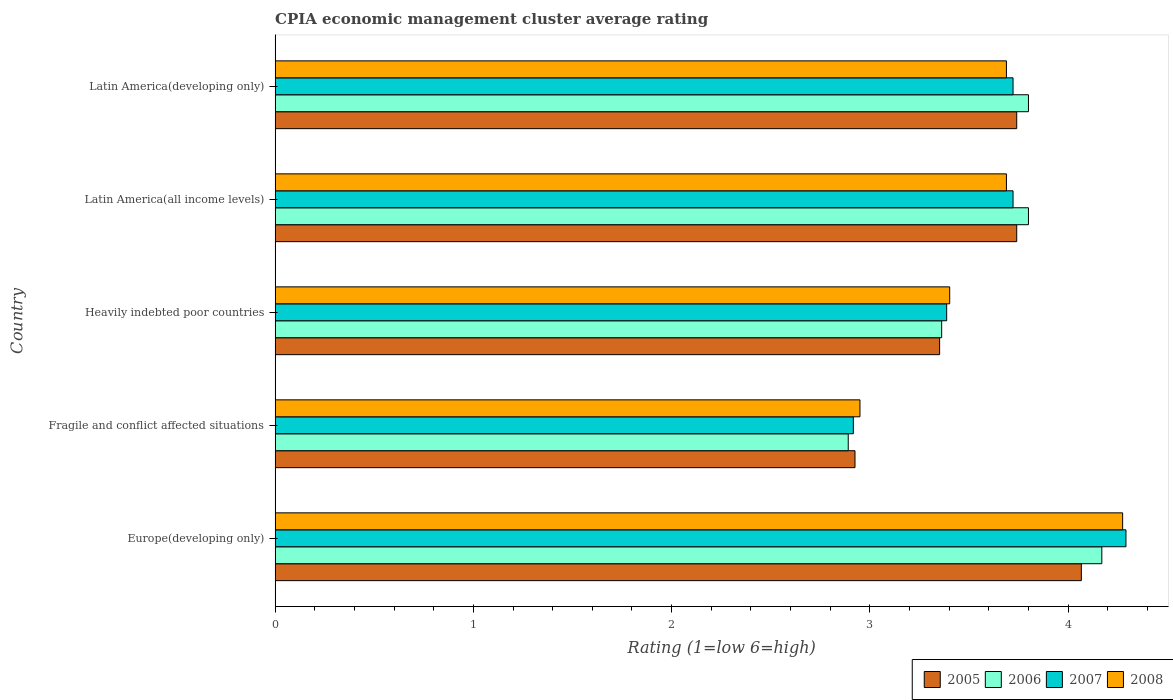Are the number of bars on each tick of the Y-axis equal?
Keep it short and to the point. Yes. How many bars are there on the 5th tick from the bottom?
Your answer should be very brief. 4. What is the label of the 3rd group of bars from the top?
Your response must be concise. Heavily indebted poor countries. In how many cases, is the number of bars for a given country not equal to the number of legend labels?
Provide a short and direct response. 0. What is the CPIA rating in 2005 in Heavily indebted poor countries?
Provide a short and direct response. 3.35. Across all countries, what is the maximum CPIA rating in 2008?
Keep it short and to the point. 4.28. Across all countries, what is the minimum CPIA rating in 2008?
Offer a terse response. 2.95. In which country was the CPIA rating in 2006 maximum?
Your answer should be compact. Europe(developing only). In which country was the CPIA rating in 2005 minimum?
Your answer should be compact. Fragile and conflict affected situations. What is the total CPIA rating in 2005 in the graph?
Your response must be concise. 17.83. What is the difference between the CPIA rating in 2006 in Latin America(all income levels) and that in Latin America(developing only)?
Give a very brief answer. 0. What is the difference between the CPIA rating in 2006 in Latin America(developing only) and the CPIA rating in 2008 in Europe(developing only)?
Your answer should be very brief. -0.48. What is the average CPIA rating in 2006 per country?
Offer a terse response. 3.6. What is the difference between the CPIA rating in 2005 and CPIA rating in 2008 in Heavily indebted poor countries?
Offer a very short reply. -0.05. In how many countries, is the CPIA rating in 2008 greater than 3.8 ?
Ensure brevity in your answer.  1. What is the ratio of the CPIA rating in 2005 in Fragile and conflict affected situations to that in Latin America(developing only)?
Your answer should be very brief. 0.78. Is the difference between the CPIA rating in 2005 in Europe(developing only) and Latin America(developing only) greater than the difference between the CPIA rating in 2008 in Europe(developing only) and Latin America(developing only)?
Provide a succinct answer. No. What is the difference between the highest and the second highest CPIA rating in 2005?
Make the answer very short. 0.33. What is the difference between the highest and the lowest CPIA rating in 2008?
Your answer should be very brief. 1.33. In how many countries, is the CPIA rating in 2006 greater than the average CPIA rating in 2006 taken over all countries?
Provide a succinct answer. 3. Is the sum of the CPIA rating in 2008 in Fragile and conflict affected situations and Heavily indebted poor countries greater than the maximum CPIA rating in 2006 across all countries?
Offer a terse response. Yes. Is it the case that in every country, the sum of the CPIA rating in 2007 and CPIA rating in 2006 is greater than the CPIA rating in 2005?
Keep it short and to the point. Yes. Are all the bars in the graph horizontal?
Keep it short and to the point. Yes. How many countries are there in the graph?
Give a very brief answer. 5. How many legend labels are there?
Make the answer very short. 4. What is the title of the graph?
Give a very brief answer. CPIA economic management cluster average rating. What is the label or title of the X-axis?
Make the answer very short. Rating (1=low 6=high). What is the Rating (1=low 6=high) in 2005 in Europe(developing only)?
Make the answer very short. 4.07. What is the Rating (1=low 6=high) of 2006 in Europe(developing only)?
Your answer should be compact. 4.17. What is the Rating (1=low 6=high) of 2007 in Europe(developing only)?
Make the answer very short. 4.29. What is the Rating (1=low 6=high) of 2008 in Europe(developing only)?
Your response must be concise. 4.28. What is the Rating (1=low 6=high) of 2005 in Fragile and conflict affected situations?
Provide a succinct answer. 2.92. What is the Rating (1=low 6=high) of 2006 in Fragile and conflict affected situations?
Your answer should be very brief. 2.89. What is the Rating (1=low 6=high) of 2007 in Fragile and conflict affected situations?
Offer a very short reply. 2.92. What is the Rating (1=low 6=high) in 2008 in Fragile and conflict affected situations?
Ensure brevity in your answer.  2.95. What is the Rating (1=low 6=high) in 2005 in Heavily indebted poor countries?
Make the answer very short. 3.35. What is the Rating (1=low 6=high) in 2006 in Heavily indebted poor countries?
Offer a terse response. 3.36. What is the Rating (1=low 6=high) of 2007 in Heavily indebted poor countries?
Keep it short and to the point. 3.39. What is the Rating (1=low 6=high) in 2008 in Heavily indebted poor countries?
Offer a terse response. 3.4. What is the Rating (1=low 6=high) in 2005 in Latin America(all income levels)?
Keep it short and to the point. 3.74. What is the Rating (1=low 6=high) in 2007 in Latin America(all income levels)?
Give a very brief answer. 3.72. What is the Rating (1=low 6=high) in 2008 in Latin America(all income levels)?
Offer a terse response. 3.69. What is the Rating (1=low 6=high) in 2005 in Latin America(developing only)?
Offer a terse response. 3.74. What is the Rating (1=low 6=high) of 2006 in Latin America(developing only)?
Provide a succinct answer. 3.8. What is the Rating (1=low 6=high) in 2007 in Latin America(developing only)?
Ensure brevity in your answer.  3.72. What is the Rating (1=low 6=high) of 2008 in Latin America(developing only)?
Your response must be concise. 3.69. Across all countries, what is the maximum Rating (1=low 6=high) of 2005?
Keep it short and to the point. 4.07. Across all countries, what is the maximum Rating (1=low 6=high) in 2006?
Your response must be concise. 4.17. Across all countries, what is the maximum Rating (1=low 6=high) in 2007?
Offer a very short reply. 4.29. Across all countries, what is the maximum Rating (1=low 6=high) of 2008?
Offer a very short reply. 4.28. Across all countries, what is the minimum Rating (1=low 6=high) in 2005?
Give a very brief answer. 2.92. Across all countries, what is the minimum Rating (1=low 6=high) in 2006?
Provide a succinct answer. 2.89. Across all countries, what is the minimum Rating (1=low 6=high) in 2007?
Your response must be concise. 2.92. Across all countries, what is the minimum Rating (1=low 6=high) in 2008?
Provide a short and direct response. 2.95. What is the total Rating (1=low 6=high) of 2005 in the graph?
Provide a short and direct response. 17.82. What is the total Rating (1=low 6=high) of 2006 in the graph?
Ensure brevity in your answer.  18.02. What is the total Rating (1=low 6=high) of 2007 in the graph?
Give a very brief answer. 18.04. What is the total Rating (1=low 6=high) in 2008 in the graph?
Offer a very short reply. 18.01. What is the difference between the Rating (1=low 6=high) of 2005 in Europe(developing only) and that in Fragile and conflict affected situations?
Keep it short and to the point. 1.14. What is the difference between the Rating (1=low 6=high) of 2006 in Europe(developing only) and that in Fragile and conflict affected situations?
Your answer should be very brief. 1.28. What is the difference between the Rating (1=low 6=high) in 2007 in Europe(developing only) and that in Fragile and conflict affected situations?
Give a very brief answer. 1.38. What is the difference between the Rating (1=low 6=high) of 2008 in Europe(developing only) and that in Fragile and conflict affected situations?
Offer a terse response. 1.32. What is the difference between the Rating (1=low 6=high) in 2005 in Europe(developing only) and that in Heavily indebted poor countries?
Provide a short and direct response. 0.71. What is the difference between the Rating (1=low 6=high) in 2006 in Europe(developing only) and that in Heavily indebted poor countries?
Provide a short and direct response. 0.81. What is the difference between the Rating (1=low 6=high) in 2007 in Europe(developing only) and that in Heavily indebted poor countries?
Offer a very short reply. 0.9. What is the difference between the Rating (1=low 6=high) of 2008 in Europe(developing only) and that in Heavily indebted poor countries?
Keep it short and to the point. 0.87. What is the difference between the Rating (1=low 6=high) in 2005 in Europe(developing only) and that in Latin America(all income levels)?
Provide a short and direct response. 0.33. What is the difference between the Rating (1=low 6=high) in 2006 in Europe(developing only) and that in Latin America(all income levels)?
Keep it short and to the point. 0.37. What is the difference between the Rating (1=low 6=high) in 2007 in Europe(developing only) and that in Latin America(all income levels)?
Provide a short and direct response. 0.57. What is the difference between the Rating (1=low 6=high) of 2008 in Europe(developing only) and that in Latin America(all income levels)?
Provide a succinct answer. 0.59. What is the difference between the Rating (1=low 6=high) in 2005 in Europe(developing only) and that in Latin America(developing only)?
Give a very brief answer. 0.33. What is the difference between the Rating (1=low 6=high) in 2006 in Europe(developing only) and that in Latin America(developing only)?
Offer a terse response. 0.37. What is the difference between the Rating (1=low 6=high) of 2007 in Europe(developing only) and that in Latin America(developing only)?
Provide a short and direct response. 0.57. What is the difference between the Rating (1=low 6=high) in 2008 in Europe(developing only) and that in Latin America(developing only)?
Your response must be concise. 0.59. What is the difference between the Rating (1=low 6=high) of 2005 in Fragile and conflict affected situations and that in Heavily indebted poor countries?
Provide a short and direct response. -0.43. What is the difference between the Rating (1=low 6=high) in 2006 in Fragile and conflict affected situations and that in Heavily indebted poor countries?
Offer a terse response. -0.47. What is the difference between the Rating (1=low 6=high) in 2007 in Fragile and conflict affected situations and that in Heavily indebted poor countries?
Make the answer very short. -0.47. What is the difference between the Rating (1=low 6=high) in 2008 in Fragile and conflict affected situations and that in Heavily indebted poor countries?
Ensure brevity in your answer.  -0.45. What is the difference between the Rating (1=low 6=high) of 2005 in Fragile and conflict affected situations and that in Latin America(all income levels)?
Provide a short and direct response. -0.82. What is the difference between the Rating (1=low 6=high) in 2006 in Fragile and conflict affected situations and that in Latin America(all income levels)?
Ensure brevity in your answer.  -0.91. What is the difference between the Rating (1=low 6=high) in 2007 in Fragile and conflict affected situations and that in Latin America(all income levels)?
Keep it short and to the point. -0.81. What is the difference between the Rating (1=low 6=high) in 2008 in Fragile and conflict affected situations and that in Latin America(all income levels)?
Provide a short and direct response. -0.74. What is the difference between the Rating (1=low 6=high) of 2005 in Fragile and conflict affected situations and that in Latin America(developing only)?
Offer a very short reply. -0.82. What is the difference between the Rating (1=low 6=high) in 2006 in Fragile and conflict affected situations and that in Latin America(developing only)?
Provide a succinct answer. -0.91. What is the difference between the Rating (1=low 6=high) in 2007 in Fragile and conflict affected situations and that in Latin America(developing only)?
Your answer should be compact. -0.81. What is the difference between the Rating (1=low 6=high) of 2008 in Fragile and conflict affected situations and that in Latin America(developing only)?
Provide a short and direct response. -0.74. What is the difference between the Rating (1=low 6=high) of 2005 in Heavily indebted poor countries and that in Latin America(all income levels)?
Provide a short and direct response. -0.39. What is the difference between the Rating (1=low 6=high) in 2006 in Heavily indebted poor countries and that in Latin America(all income levels)?
Keep it short and to the point. -0.44. What is the difference between the Rating (1=low 6=high) in 2007 in Heavily indebted poor countries and that in Latin America(all income levels)?
Provide a short and direct response. -0.33. What is the difference between the Rating (1=low 6=high) in 2008 in Heavily indebted poor countries and that in Latin America(all income levels)?
Your answer should be very brief. -0.29. What is the difference between the Rating (1=low 6=high) in 2005 in Heavily indebted poor countries and that in Latin America(developing only)?
Make the answer very short. -0.39. What is the difference between the Rating (1=low 6=high) of 2006 in Heavily indebted poor countries and that in Latin America(developing only)?
Ensure brevity in your answer.  -0.44. What is the difference between the Rating (1=low 6=high) in 2007 in Heavily indebted poor countries and that in Latin America(developing only)?
Your answer should be compact. -0.33. What is the difference between the Rating (1=low 6=high) in 2008 in Heavily indebted poor countries and that in Latin America(developing only)?
Provide a short and direct response. -0.29. What is the difference between the Rating (1=low 6=high) of 2007 in Latin America(all income levels) and that in Latin America(developing only)?
Provide a short and direct response. 0. What is the difference between the Rating (1=low 6=high) of 2005 in Europe(developing only) and the Rating (1=low 6=high) of 2006 in Fragile and conflict affected situations?
Your answer should be compact. 1.18. What is the difference between the Rating (1=low 6=high) in 2005 in Europe(developing only) and the Rating (1=low 6=high) in 2007 in Fragile and conflict affected situations?
Offer a very short reply. 1.15. What is the difference between the Rating (1=low 6=high) in 2005 in Europe(developing only) and the Rating (1=low 6=high) in 2008 in Fragile and conflict affected situations?
Provide a succinct answer. 1.12. What is the difference between the Rating (1=low 6=high) in 2006 in Europe(developing only) and the Rating (1=low 6=high) in 2007 in Fragile and conflict affected situations?
Your response must be concise. 1.25. What is the difference between the Rating (1=low 6=high) in 2006 in Europe(developing only) and the Rating (1=low 6=high) in 2008 in Fragile and conflict affected situations?
Provide a succinct answer. 1.22. What is the difference between the Rating (1=low 6=high) in 2007 in Europe(developing only) and the Rating (1=low 6=high) in 2008 in Fragile and conflict affected situations?
Ensure brevity in your answer.  1.34. What is the difference between the Rating (1=low 6=high) in 2005 in Europe(developing only) and the Rating (1=low 6=high) in 2006 in Heavily indebted poor countries?
Keep it short and to the point. 0.7. What is the difference between the Rating (1=low 6=high) of 2005 in Europe(developing only) and the Rating (1=low 6=high) of 2007 in Heavily indebted poor countries?
Offer a very short reply. 0.68. What is the difference between the Rating (1=low 6=high) in 2005 in Europe(developing only) and the Rating (1=low 6=high) in 2008 in Heavily indebted poor countries?
Your answer should be compact. 0.66. What is the difference between the Rating (1=low 6=high) in 2006 in Europe(developing only) and the Rating (1=low 6=high) in 2007 in Heavily indebted poor countries?
Offer a very short reply. 0.78. What is the difference between the Rating (1=low 6=high) in 2006 in Europe(developing only) and the Rating (1=low 6=high) in 2008 in Heavily indebted poor countries?
Your answer should be very brief. 0.77. What is the difference between the Rating (1=low 6=high) of 2007 in Europe(developing only) and the Rating (1=low 6=high) of 2008 in Heavily indebted poor countries?
Your answer should be very brief. 0.89. What is the difference between the Rating (1=low 6=high) in 2005 in Europe(developing only) and the Rating (1=low 6=high) in 2006 in Latin America(all income levels)?
Provide a short and direct response. 0.27. What is the difference between the Rating (1=low 6=high) in 2005 in Europe(developing only) and the Rating (1=low 6=high) in 2007 in Latin America(all income levels)?
Provide a short and direct response. 0.34. What is the difference between the Rating (1=low 6=high) of 2005 in Europe(developing only) and the Rating (1=low 6=high) of 2008 in Latin America(all income levels)?
Ensure brevity in your answer.  0.38. What is the difference between the Rating (1=low 6=high) in 2006 in Europe(developing only) and the Rating (1=low 6=high) in 2007 in Latin America(all income levels)?
Keep it short and to the point. 0.45. What is the difference between the Rating (1=low 6=high) in 2006 in Europe(developing only) and the Rating (1=low 6=high) in 2008 in Latin America(all income levels)?
Keep it short and to the point. 0.48. What is the difference between the Rating (1=low 6=high) in 2007 in Europe(developing only) and the Rating (1=low 6=high) in 2008 in Latin America(all income levels)?
Your answer should be very brief. 0.6. What is the difference between the Rating (1=low 6=high) of 2005 in Europe(developing only) and the Rating (1=low 6=high) of 2006 in Latin America(developing only)?
Offer a terse response. 0.27. What is the difference between the Rating (1=low 6=high) of 2005 in Europe(developing only) and the Rating (1=low 6=high) of 2007 in Latin America(developing only)?
Provide a short and direct response. 0.34. What is the difference between the Rating (1=low 6=high) in 2005 in Europe(developing only) and the Rating (1=low 6=high) in 2008 in Latin America(developing only)?
Keep it short and to the point. 0.38. What is the difference between the Rating (1=low 6=high) of 2006 in Europe(developing only) and the Rating (1=low 6=high) of 2007 in Latin America(developing only)?
Give a very brief answer. 0.45. What is the difference between the Rating (1=low 6=high) of 2006 in Europe(developing only) and the Rating (1=low 6=high) of 2008 in Latin America(developing only)?
Keep it short and to the point. 0.48. What is the difference between the Rating (1=low 6=high) in 2007 in Europe(developing only) and the Rating (1=low 6=high) in 2008 in Latin America(developing only)?
Ensure brevity in your answer.  0.6. What is the difference between the Rating (1=low 6=high) of 2005 in Fragile and conflict affected situations and the Rating (1=low 6=high) of 2006 in Heavily indebted poor countries?
Offer a terse response. -0.44. What is the difference between the Rating (1=low 6=high) of 2005 in Fragile and conflict affected situations and the Rating (1=low 6=high) of 2007 in Heavily indebted poor countries?
Your answer should be very brief. -0.46. What is the difference between the Rating (1=low 6=high) of 2005 in Fragile and conflict affected situations and the Rating (1=low 6=high) of 2008 in Heavily indebted poor countries?
Offer a terse response. -0.48. What is the difference between the Rating (1=low 6=high) in 2006 in Fragile and conflict affected situations and the Rating (1=low 6=high) in 2007 in Heavily indebted poor countries?
Your answer should be compact. -0.5. What is the difference between the Rating (1=low 6=high) of 2006 in Fragile and conflict affected situations and the Rating (1=low 6=high) of 2008 in Heavily indebted poor countries?
Provide a short and direct response. -0.51. What is the difference between the Rating (1=low 6=high) of 2007 in Fragile and conflict affected situations and the Rating (1=low 6=high) of 2008 in Heavily indebted poor countries?
Provide a succinct answer. -0.49. What is the difference between the Rating (1=low 6=high) of 2005 in Fragile and conflict affected situations and the Rating (1=low 6=high) of 2006 in Latin America(all income levels)?
Give a very brief answer. -0.88. What is the difference between the Rating (1=low 6=high) in 2005 in Fragile and conflict affected situations and the Rating (1=low 6=high) in 2007 in Latin America(all income levels)?
Offer a terse response. -0.8. What is the difference between the Rating (1=low 6=high) of 2005 in Fragile and conflict affected situations and the Rating (1=low 6=high) of 2008 in Latin America(all income levels)?
Provide a short and direct response. -0.76. What is the difference between the Rating (1=low 6=high) of 2006 in Fragile and conflict affected situations and the Rating (1=low 6=high) of 2007 in Latin America(all income levels)?
Give a very brief answer. -0.83. What is the difference between the Rating (1=low 6=high) in 2006 in Fragile and conflict affected situations and the Rating (1=low 6=high) in 2008 in Latin America(all income levels)?
Make the answer very short. -0.8. What is the difference between the Rating (1=low 6=high) in 2007 in Fragile and conflict affected situations and the Rating (1=low 6=high) in 2008 in Latin America(all income levels)?
Offer a terse response. -0.77. What is the difference between the Rating (1=low 6=high) in 2005 in Fragile and conflict affected situations and the Rating (1=low 6=high) in 2006 in Latin America(developing only)?
Offer a very short reply. -0.88. What is the difference between the Rating (1=low 6=high) in 2005 in Fragile and conflict affected situations and the Rating (1=low 6=high) in 2007 in Latin America(developing only)?
Your answer should be very brief. -0.8. What is the difference between the Rating (1=low 6=high) of 2005 in Fragile and conflict affected situations and the Rating (1=low 6=high) of 2008 in Latin America(developing only)?
Give a very brief answer. -0.76. What is the difference between the Rating (1=low 6=high) of 2006 in Fragile and conflict affected situations and the Rating (1=low 6=high) of 2007 in Latin America(developing only)?
Offer a terse response. -0.83. What is the difference between the Rating (1=low 6=high) of 2006 in Fragile and conflict affected situations and the Rating (1=low 6=high) of 2008 in Latin America(developing only)?
Your answer should be compact. -0.8. What is the difference between the Rating (1=low 6=high) of 2007 in Fragile and conflict affected situations and the Rating (1=low 6=high) of 2008 in Latin America(developing only)?
Keep it short and to the point. -0.77. What is the difference between the Rating (1=low 6=high) in 2005 in Heavily indebted poor countries and the Rating (1=low 6=high) in 2006 in Latin America(all income levels)?
Give a very brief answer. -0.45. What is the difference between the Rating (1=low 6=high) of 2005 in Heavily indebted poor countries and the Rating (1=low 6=high) of 2007 in Latin America(all income levels)?
Your answer should be very brief. -0.37. What is the difference between the Rating (1=low 6=high) of 2005 in Heavily indebted poor countries and the Rating (1=low 6=high) of 2008 in Latin America(all income levels)?
Offer a very short reply. -0.34. What is the difference between the Rating (1=low 6=high) of 2006 in Heavily indebted poor countries and the Rating (1=low 6=high) of 2007 in Latin America(all income levels)?
Provide a succinct answer. -0.36. What is the difference between the Rating (1=low 6=high) in 2006 in Heavily indebted poor countries and the Rating (1=low 6=high) in 2008 in Latin America(all income levels)?
Provide a short and direct response. -0.33. What is the difference between the Rating (1=low 6=high) of 2007 in Heavily indebted poor countries and the Rating (1=low 6=high) of 2008 in Latin America(all income levels)?
Offer a very short reply. -0.3. What is the difference between the Rating (1=low 6=high) in 2005 in Heavily indebted poor countries and the Rating (1=low 6=high) in 2006 in Latin America(developing only)?
Provide a succinct answer. -0.45. What is the difference between the Rating (1=low 6=high) of 2005 in Heavily indebted poor countries and the Rating (1=low 6=high) of 2007 in Latin America(developing only)?
Provide a short and direct response. -0.37. What is the difference between the Rating (1=low 6=high) of 2005 in Heavily indebted poor countries and the Rating (1=low 6=high) of 2008 in Latin America(developing only)?
Your answer should be compact. -0.34. What is the difference between the Rating (1=low 6=high) of 2006 in Heavily indebted poor countries and the Rating (1=low 6=high) of 2007 in Latin America(developing only)?
Keep it short and to the point. -0.36. What is the difference between the Rating (1=low 6=high) in 2006 in Heavily indebted poor countries and the Rating (1=low 6=high) in 2008 in Latin America(developing only)?
Provide a succinct answer. -0.33. What is the difference between the Rating (1=low 6=high) in 2007 in Heavily indebted poor countries and the Rating (1=low 6=high) in 2008 in Latin America(developing only)?
Ensure brevity in your answer.  -0.3. What is the difference between the Rating (1=low 6=high) in 2005 in Latin America(all income levels) and the Rating (1=low 6=high) in 2006 in Latin America(developing only)?
Provide a succinct answer. -0.06. What is the difference between the Rating (1=low 6=high) in 2005 in Latin America(all income levels) and the Rating (1=low 6=high) in 2007 in Latin America(developing only)?
Ensure brevity in your answer.  0.02. What is the difference between the Rating (1=low 6=high) in 2005 in Latin America(all income levels) and the Rating (1=low 6=high) in 2008 in Latin America(developing only)?
Ensure brevity in your answer.  0.05. What is the difference between the Rating (1=low 6=high) of 2006 in Latin America(all income levels) and the Rating (1=low 6=high) of 2007 in Latin America(developing only)?
Ensure brevity in your answer.  0.08. What is the difference between the Rating (1=low 6=high) of 2006 in Latin America(all income levels) and the Rating (1=low 6=high) of 2008 in Latin America(developing only)?
Ensure brevity in your answer.  0.11. What is the average Rating (1=low 6=high) of 2005 per country?
Your answer should be very brief. 3.56. What is the average Rating (1=low 6=high) in 2006 per country?
Give a very brief answer. 3.6. What is the average Rating (1=low 6=high) of 2007 per country?
Your answer should be compact. 3.61. What is the average Rating (1=low 6=high) of 2008 per country?
Give a very brief answer. 3.6. What is the difference between the Rating (1=low 6=high) in 2005 and Rating (1=low 6=high) in 2006 in Europe(developing only)?
Ensure brevity in your answer.  -0.1. What is the difference between the Rating (1=low 6=high) in 2005 and Rating (1=low 6=high) in 2007 in Europe(developing only)?
Ensure brevity in your answer.  -0.23. What is the difference between the Rating (1=low 6=high) in 2005 and Rating (1=low 6=high) in 2008 in Europe(developing only)?
Offer a very short reply. -0.21. What is the difference between the Rating (1=low 6=high) of 2006 and Rating (1=low 6=high) of 2007 in Europe(developing only)?
Ensure brevity in your answer.  -0.12. What is the difference between the Rating (1=low 6=high) of 2006 and Rating (1=low 6=high) of 2008 in Europe(developing only)?
Your response must be concise. -0.1. What is the difference between the Rating (1=low 6=high) in 2007 and Rating (1=low 6=high) in 2008 in Europe(developing only)?
Keep it short and to the point. 0.02. What is the difference between the Rating (1=low 6=high) in 2005 and Rating (1=low 6=high) in 2006 in Fragile and conflict affected situations?
Offer a very short reply. 0.03. What is the difference between the Rating (1=low 6=high) in 2005 and Rating (1=low 6=high) in 2007 in Fragile and conflict affected situations?
Keep it short and to the point. 0.01. What is the difference between the Rating (1=low 6=high) of 2005 and Rating (1=low 6=high) of 2008 in Fragile and conflict affected situations?
Provide a short and direct response. -0.03. What is the difference between the Rating (1=low 6=high) in 2006 and Rating (1=low 6=high) in 2007 in Fragile and conflict affected situations?
Offer a very short reply. -0.03. What is the difference between the Rating (1=low 6=high) in 2006 and Rating (1=low 6=high) in 2008 in Fragile and conflict affected situations?
Offer a terse response. -0.06. What is the difference between the Rating (1=low 6=high) in 2007 and Rating (1=low 6=high) in 2008 in Fragile and conflict affected situations?
Make the answer very short. -0.03. What is the difference between the Rating (1=low 6=high) of 2005 and Rating (1=low 6=high) of 2006 in Heavily indebted poor countries?
Ensure brevity in your answer.  -0.01. What is the difference between the Rating (1=low 6=high) of 2005 and Rating (1=low 6=high) of 2007 in Heavily indebted poor countries?
Make the answer very short. -0.04. What is the difference between the Rating (1=low 6=high) in 2005 and Rating (1=low 6=high) in 2008 in Heavily indebted poor countries?
Your response must be concise. -0.05. What is the difference between the Rating (1=low 6=high) in 2006 and Rating (1=low 6=high) in 2007 in Heavily indebted poor countries?
Provide a succinct answer. -0.03. What is the difference between the Rating (1=low 6=high) of 2006 and Rating (1=low 6=high) of 2008 in Heavily indebted poor countries?
Your answer should be very brief. -0.04. What is the difference between the Rating (1=low 6=high) in 2007 and Rating (1=low 6=high) in 2008 in Heavily indebted poor countries?
Offer a terse response. -0.02. What is the difference between the Rating (1=low 6=high) in 2005 and Rating (1=low 6=high) in 2006 in Latin America(all income levels)?
Offer a terse response. -0.06. What is the difference between the Rating (1=low 6=high) of 2005 and Rating (1=low 6=high) of 2007 in Latin America(all income levels)?
Give a very brief answer. 0.02. What is the difference between the Rating (1=low 6=high) in 2005 and Rating (1=low 6=high) in 2008 in Latin America(all income levels)?
Give a very brief answer. 0.05. What is the difference between the Rating (1=low 6=high) in 2006 and Rating (1=low 6=high) in 2007 in Latin America(all income levels)?
Keep it short and to the point. 0.08. What is the difference between the Rating (1=low 6=high) of 2007 and Rating (1=low 6=high) of 2008 in Latin America(all income levels)?
Your answer should be very brief. 0.03. What is the difference between the Rating (1=low 6=high) of 2005 and Rating (1=low 6=high) of 2006 in Latin America(developing only)?
Your answer should be compact. -0.06. What is the difference between the Rating (1=low 6=high) of 2005 and Rating (1=low 6=high) of 2007 in Latin America(developing only)?
Keep it short and to the point. 0.02. What is the difference between the Rating (1=low 6=high) of 2005 and Rating (1=low 6=high) of 2008 in Latin America(developing only)?
Ensure brevity in your answer.  0.05. What is the difference between the Rating (1=low 6=high) in 2006 and Rating (1=low 6=high) in 2007 in Latin America(developing only)?
Keep it short and to the point. 0.08. What is the difference between the Rating (1=low 6=high) of 2006 and Rating (1=low 6=high) of 2008 in Latin America(developing only)?
Keep it short and to the point. 0.11. What is the difference between the Rating (1=low 6=high) in 2007 and Rating (1=low 6=high) in 2008 in Latin America(developing only)?
Provide a succinct answer. 0.03. What is the ratio of the Rating (1=low 6=high) of 2005 in Europe(developing only) to that in Fragile and conflict affected situations?
Provide a succinct answer. 1.39. What is the ratio of the Rating (1=low 6=high) of 2006 in Europe(developing only) to that in Fragile and conflict affected situations?
Your response must be concise. 1.44. What is the ratio of the Rating (1=low 6=high) of 2007 in Europe(developing only) to that in Fragile and conflict affected situations?
Give a very brief answer. 1.47. What is the ratio of the Rating (1=low 6=high) of 2008 in Europe(developing only) to that in Fragile and conflict affected situations?
Provide a short and direct response. 1.45. What is the ratio of the Rating (1=low 6=high) of 2005 in Europe(developing only) to that in Heavily indebted poor countries?
Your response must be concise. 1.21. What is the ratio of the Rating (1=low 6=high) of 2006 in Europe(developing only) to that in Heavily indebted poor countries?
Make the answer very short. 1.24. What is the ratio of the Rating (1=low 6=high) in 2007 in Europe(developing only) to that in Heavily indebted poor countries?
Ensure brevity in your answer.  1.27. What is the ratio of the Rating (1=low 6=high) of 2008 in Europe(developing only) to that in Heavily indebted poor countries?
Your response must be concise. 1.26. What is the ratio of the Rating (1=low 6=high) in 2005 in Europe(developing only) to that in Latin America(all income levels)?
Give a very brief answer. 1.09. What is the ratio of the Rating (1=low 6=high) in 2006 in Europe(developing only) to that in Latin America(all income levels)?
Your answer should be very brief. 1.1. What is the ratio of the Rating (1=low 6=high) in 2007 in Europe(developing only) to that in Latin America(all income levels)?
Ensure brevity in your answer.  1.15. What is the ratio of the Rating (1=low 6=high) in 2008 in Europe(developing only) to that in Latin America(all income levels)?
Your answer should be very brief. 1.16. What is the ratio of the Rating (1=low 6=high) in 2005 in Europe(developing only) to that in Latin America(developing only)?
Give a very brief answer. 1.09. What is the ratio of the Rating (1=low 6=high) in 2006 in Europe(developing only) to that in Latin America(developing only)?
Offer a very short reply. 1.1. What is the ratio of the Rating (1=low 6=high) of 2007 in Europe(developing only) to that in Latin America(developing only)?
Your answer should be very brief. 1.15. What is the ratio of the Rating (1=low 6=high) of 2008 in Europe(developing only) to that in Latin America(developing only)?
Your answer should be compact. 1.16. What is the ratio of the Rating (1=low 6=high) of 2005 in Fragile and conflict affected situations to that in Heavily indebted poor countries?
Keep it short and to the point. 0.87. What is the ratio of the Rating (1=low 6=high) of 2006 in Fragile and conflict affected situations to that in Heavily indebted poor countries?
Your answer should be compact. 0.86. What is the ratio of the Rating (1=low 6=high) of 2007 in Fragile and conflict affected situations to that in Heavily indebted poor countries?
Your answer should be very brief. 0.86. What is the ratio of the Rating (1=low 6=high) in 2008 in Fragile and conflict affected situations to that in Heavily indebted poor countries?
Make the answer very short. 0.87. What is the ratio of the Rating (1=low 6=high) in 2005 in Fragile and conflict affected situations to that in Latin America(all income levels)?
Make the answer very short. 0.78. What is the ratio of the Rating (1=low 6=high) in 2006 in Fragile and conflict affected situations to that in Latin America(all income levels)?
Your answer should be very brief. 0.76. What is the ratio of the Rating (1=low 6=high) in 2007 in Fragile and conflict affected situations to that in Latin America(all income levels)?
Your response must be concise. 0.78. What is the ratio of the Rating (1=low 6=high) in 2008 in Fragile and conflict affected situations to that in Latin America(all income levels)?
Give a very brief answer. 0.8. What is the ratio of the Rating (1=low 6=high) in 2005 in Fragile and conflict affected situations to that in Latin America(developing only)?
Give a very brief answer. 0.78. What is the ratio of the Rating (1=low 6=high) of 2006 in Fragile and conflict affected situations to that in Latin America(developing only)?
Provide a short and direct response. 0.76. What is the ratio of the Rating (1=low 6=high) of 2007 in Fragile and conflict affected situations to that in Latin America(developing only)?
Give a very brief answer. 0.78. What is the ratio of the Rating (1=low 6=high) of 2008 in Fragile and conflict affected situations to that in Latin America(developing only)?
Your answer should be compact. 0.8. What is the ratio of the Rating (1=low 6=high) of 2005 in Heavily indebted poor countries to that in Latin America(all income levels)?
Keep it short and to the point. 0.9. What is the ratio of the Rating (1=low 6=high) of 2006 in Heavily indebted poor countries to that in Latin America(all income levels)?
Offer a very short reply. 0.88. What is the ratio of the Rating (1=low 6=high) of 2007 in Heavily indebted poor countries to that in Latin America(all income levels)?
Your answer should be very brief. 0.91. What is the ratio of the Rating (1=low 6=high) of 2008 in Heavily indebted poor countries to that in Latin America(all income levels)?
Make the answer very short. 0.92. What is the ratio of the Rating (1=low 6=high) of 2005 in Heavily indebted poor countries to that in Latin America(developing only)?
Make the answer very short. 0.9. What is the ratio of the Rating (1=low 6=high) in 2006 in Heavily indebted poor countries to that in Latin America(developing only)?
Offer a very short reply. 0.88. What is the ratio of the Rating (1=low 6=high) in 2007 in Heavily indebted poor countries to that in Latin America(developing only)?
Your answer should be very brief. 0.91. What is the ratio of the Rating (1=low 6=high) in 2008 in Heavily indebted poor countries to that in Latin America(developing only)?
Ensure brevity in your answer.  0.92. What is the ratio of the Rating (1=low 6=high) in 2006 in Latin America(all income levels) to that in Latin America(developing only)?
Provide a succinct answer. 1. What is the difference between the highest and the second highest Rating (1=low 6=high) of 2005?
Your answer should be very brief. 0.33. What is the difference between the highest and the second highest Rating (1=low 6=high) of 2006?
Your response must be concise. 0.37. What is the difference between the highest and the second highest Rating (1=low 6=high) of 2007?
Give a very brief answer. 0.57. What is the difference between the highest and the second highest Rating (1=low 6=high) of 2008?
Give a very brief answer. 0.59. What is the difference between the highest and the lowest Rating (1=low 6=high) in 2005?
Your answer should be compact. 1.14. What is the difference between the highest and the lowest Rating (1=low 6=high) in 2006?
Your answer should be compact. 1.28. What is the difference between the highest and the lowest Rating (1=low 6=high) in 2007?
Keep it short and to the point. 1.38. What is the difference between the highest and the lowest Rating (1=low 6=high) of 2008?
Offer a terse response. 1.32. 